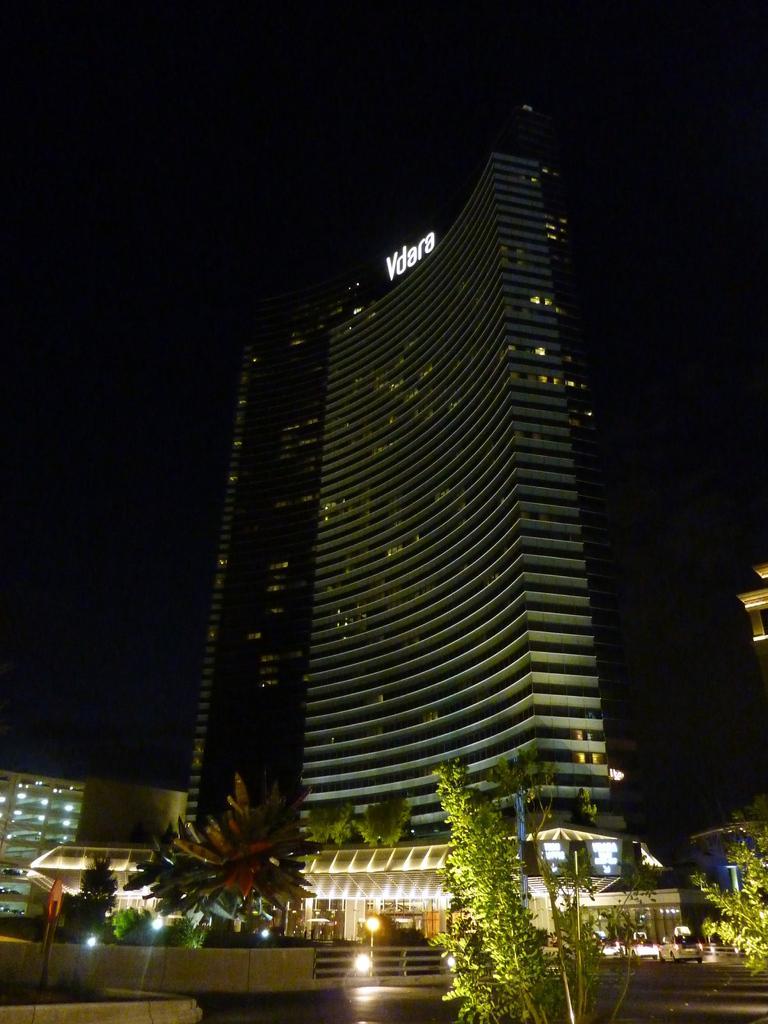How would you summarize this image in a sentence or two? In the foreground I can see a pole, trees, fence, lights, vehicles on the road and buildings. In the background I can see the sky. This image is taken during night. 